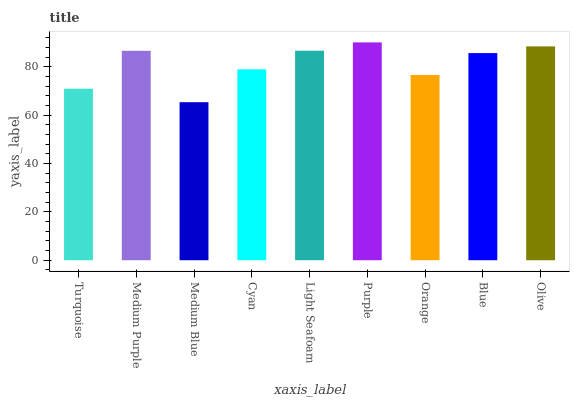Is Medium Blue the minimum?
Answer yes or no. Yes. Is Purple the maximum?
Answer yes or no. Yes. Is Medium Purple the minimum?
Answer yes or no. No. Is Medium Purple the maximum?
Answer yes or no. No. Is Medium Purple greater than Turquoise?
Answer yes or no. Yes. Is Turquoise less than Medium Purple?
Answer yes or no. Yes. Is Turquoise greater than Medium Purple?
Answer yes or no. No. Is Medium Purple less than Turquoise?
Answer yes or no. No. Is Blue the high median?
Answer yes or no. Yes. Is Blue the low median?
Answer yes or no. Yes. Is Purple the high median?
Answer yes or no. No. Is Cyan the low median?
Answer yes or no. No. 